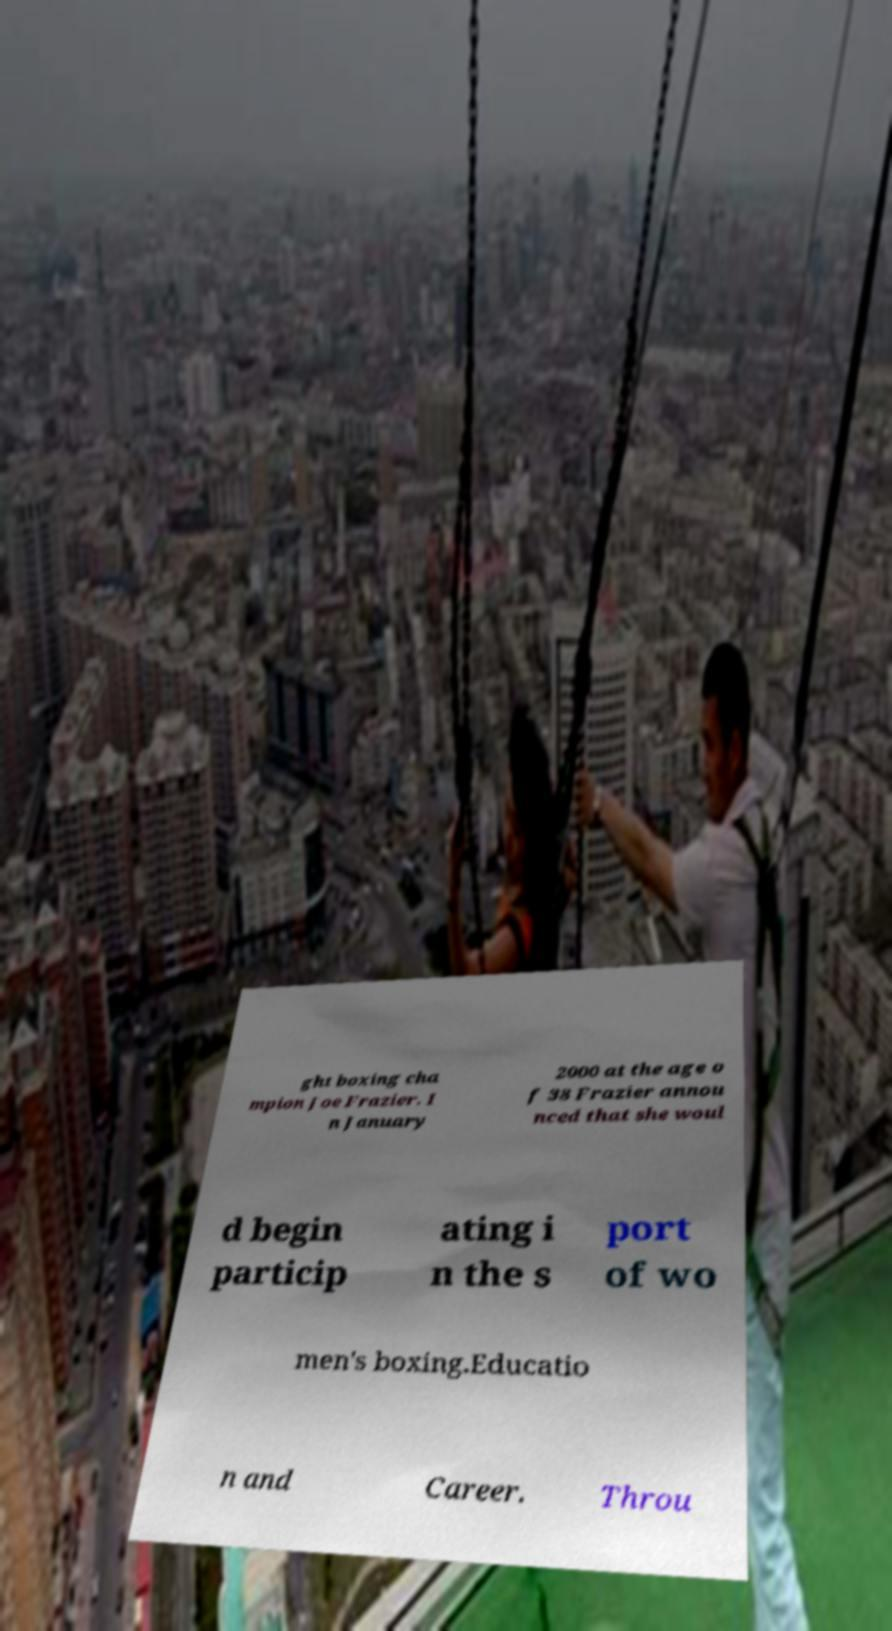I need the written content from this picture converted into text. Can you do that? ght boxing cha mpion Joe Frazier. I n January 2000 at the age o f 38 Frazier annou nced that she woul d begin particip ating i n the s port of wo men's boxing.Educatio n and Career. Throu 